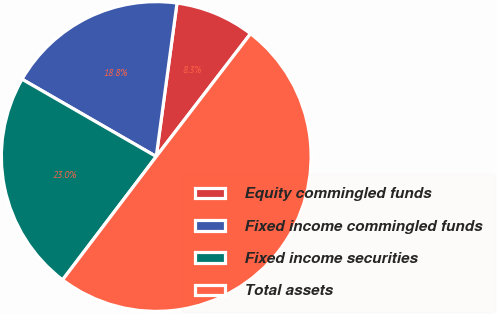Convert chart. <chart><loc_0><loc_0><loc_500><loc_500><pie_chart><fcel>Equity commingled funds<fcel>Fixed income commingled funds<fcel>Fixed income securities<fcel>Total assets<nl><fcel>8.28%<fcel>18.82%<fcel>22.98%<fcel>49.91%<nl></chart> 